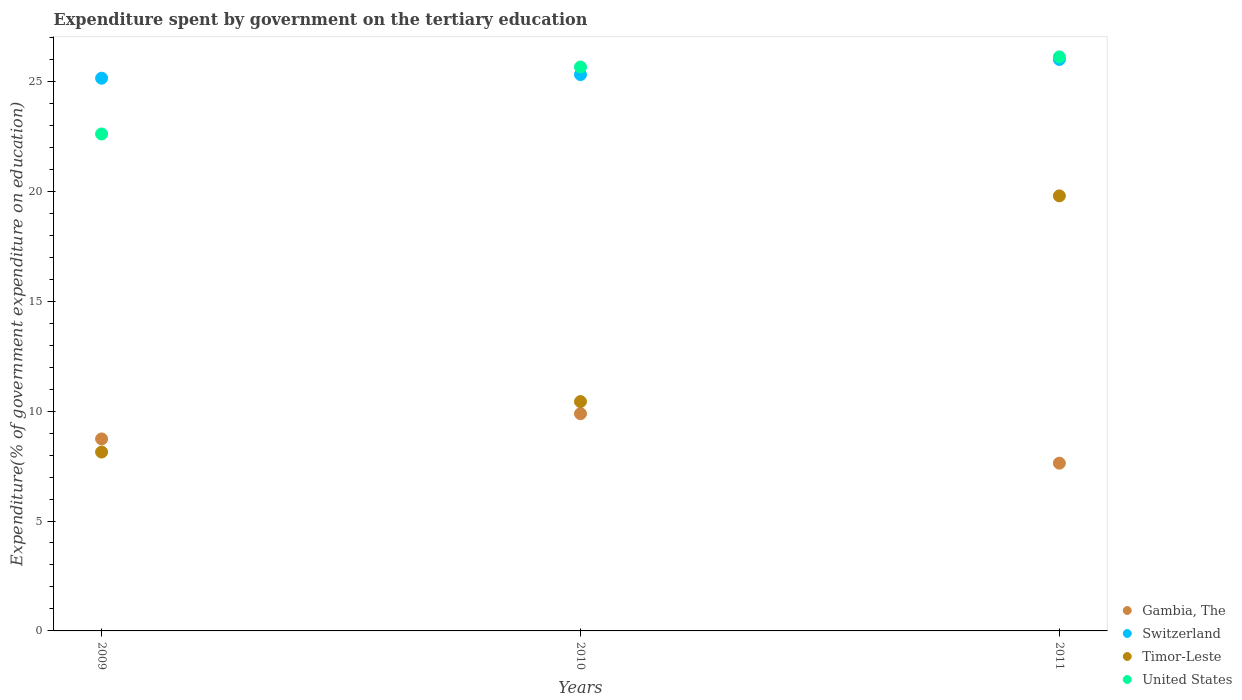What is the expenditure spent by government on the tertiary education in United States in 2011?
Your answer should be compact. 26.11. Across all years, what is the maximum expenditure spent by government on the tertiary education in Switzerland?
Provide a succinct answer. 26. Across all years, what is the minimum expenditure spent by government on the tertiary education in Gambia, The?
Keep it short and to the point. 7.63. In which year was the expenditure spent by government on the tertiary education in Switzerland maximum?
Keep it short and to the point. 2011. What is the total expenditure spent by government on the tertiary education in United States in the graph?
Your response must be concise. 74.37. What is the difference between the expenditure spent by government on the tertiary education in Switzerland in 2009 and that in 2010?
Offer a very short reply. -0.16. What is the difference between the expenditure spent by government on the tertiary education in Timor-Leste in 2010 and the expenditure spent by government on the tertiary education in Gambia, The in 2009?
Make the answer very short. 1.7. What is the average expenditure spent by government on the tertiary education in United States per year?
Your answer should be very brief. 24.79. In the year 2009, what is the difference between the expenditure spent by government on the tertiary education in United States and expenditure spent by government on the tertiary education in Timor-Leste?
Make the answer very short. 14.47. What is the ratio of the expenditure spent by government on the tertiary education in United States in 2009 to that in 2011?
Ensure brevity in your answer.  0.87. Is the expenditure spent by government on the tertiary education in United States in 2009 less than that in 2010?
Provide a short and direct response. Yes. What is the difference between the highest and the second highest expenditure spent by government on the tertiary education in Gambia, The?
Your answer should be very brief. 1.15. What is the difference between the highest and the lowest expenditure spent by government on the tertiary education in United States?
Your answer should be compact. 3.51. Is it the case that in every year, the sum of the expenditure spent by government on the tertiary education in Switzerland and expenditure spent by government on the tertiary education in Timor-Leste  is greater than the sum of expenditure spent by government on the tertiary education in Gambia, The and expenditure spent by government on the tertiary education in United States?
Ensure brevity in your answer.  Yes. Is it the case that in every year, the sum of the expenditure spent by government on the tertiary education in United States and expenditure spent by government on the tertiary education in Timor-Leste  is greater than the expenditure spent by government on the tertiary education in Gambia, The?
Offer a very short reply. Yes. Is the expenditure spent by government on the tertiary education in United States strictly greater than the expenditure spent by government on the tertiary education in Gambia, The over the years?
Offer a terse response. Yes. How many dotlines are there?
Keep it short and to the point. 4. How many years are there in the graph?
Your answer should be compact. 3. What is the difference between two consecutive major ticks on the Y-axis?
Offer a very short reply. 5. Are the values on the major ticks of Y-axis written in scientific E-notation?
Your answer should be very brief. No. Does the graph contain grids?
Your answer should be very brief. No. Where does the legend appear in the graph?
Your answer should be compact. Bottom right. What is the title of the graph?
Keep it short and to the point. Expenditure spent by government on the tertiary education. Does "Iraq" appear as one of the legend labels in the graph?
Keep it short and to the point. No. What is the label or title of the Y-axis?
Ensure brevity in your answer.  Expenditure(% of government expenditure on education). What is the Expenditure(% of government expenditure on education) of Gambia, The in 2009?
Your answer should be compact. 8.73. What is the Expenditure(% of government expenditure on education) of Switzerland in 2009?
Give a very brief answer. 25.14. What is the Expenditure(% of government expenditure on education) of Timor-Leste in 2009?
Your answer should be very brief. 8.14. What is the Expenditure(% of government expenditure on education) of United States in 2009?
Keep it short and to the point. 22.61. What is the Expenditure(% of government expenditure on education) of Gambia, The in 2010?
Make the answer very short. 9.88. What is the Expenditure(% of government expenditure on education) in Switzerland in 2010?
Your answer should be compact. 25.31. What is the Expenditure(% of government expenditure on education) in Timor-Leste in 2010?
Your answer should be very brief. 10.43. What is the Expenditure(% of government expenditure on education) of United States in 2010?
Your answer should be very brief. 25.65. What is the Expenditure(% of government expenditure on education) of Gambia, The in 2011?
Offer a terse response. 7.63. What is the Expenditure(% of government expenditure on education) in Switzerland in 2011?
Make the answer very short. 26. What is the Expenditure(% of government expenditure on education) in Timor-Leste in 2011?
Offer a terse response. 19.79. What is the Expenditure(% of government expenditure on education) in United States in 2011?
Provide a succinct answer. 26.11. Across all years, what is the maximum Expenditure(% of government expenditure on education) in Gambia, The?
Provide a succinct answer. 9.88. Across all years, what is the maximum Expenditure(% of government expenditure on education) in Switzerland?
Your answer should be very brief. 26. Across all years, what is the maximum Expenditure(% of government expenditure on education) in Timor-Leste?
Provide a succinct answer. 19.79. Across all years, what is the maximum Expenditure(% of government expenditure on education) of United States?
Offer a terse response. 26.11. Across all years, what is the minimum Expenditure(% of government expenditure on education) in Gambia, The?
Your answer should be very brief. 7.63. Across all years, what is the minimum Expenditure(% of government expenditure on education) of Switzerland?
Ensure brevity in your answer.  25.14. Across all years, what is the minimum Expenditure(% of government expenditure on education) in Timor-Leste?
Offer a terse response. 8.14. Across all years, what is the minimum Expenditure(% of government expenditure on education) of United States?
Offer a terse response. 22.61. What is the total Expenditure(% of government expenditure on education) in Gambia, The in the graph?
Make the answer very short. 26.25. What is the total Expenditure(% of government expenditure on education) of Switzerland in the graph?
Make the answer very short. 76.45. What is the total Expenditure(% of government expenditure on education) of Timor-Leste in the graph?
Your answer should be very brief. 38.36. What is the total Expenditure(% of government expenditure on education) of United States in the graph?
Ensure brevity in your answer.  74.37. What is the difference between the Expenditure(% of government expenditure on education) in Gambia, The in 2009 and that in 2010?
Provide a short and direct response. -1.15. What is the difference between the Expenditure(% of government expenditure on education) in Switzerland in 2009 and that in 2010?
Give a very brief answer. -0.16. What is the difference between the Expenditure(% of government expenditure on education) of Timor-Leste in 2009 and that in 2010?
Your answer should be compact. -2.3. What is the difference between the Expenditure(% of government expenditure on education) in United States in 2009 and that in 2010?
Give a very brief answer. -3.05. What is the difference between the Expenditure(% of government expenditure on education) in Gambia, The in 2009 and that in 2011?
Your answer should be compact. 1.1. What is the difference between the Expenditure(% of government expenditure on education) of Switzerland in 2009 and that in 2011?
Your answer should be very brief. -0.85. What is the difference between the Expenditure(% of government expenditure on education) of Timor-Leste in 2009 and that in 2011?
Provide a short and direct response. -11.65. What is the difference between the Expenditure(% of government expenditure on education) of United States in 2009 and that in 2011?
Offer a terse response. -3.51. What is the difference between the Expenditure(% of government expenditure on education) in Gambia, The in 2010 and that in 2011?
Offer a very short reply. 2.25. What is the difference between the Expenditure(% of government expenditure on education) in Switzerland in 2010 and that in 2011?
Offer a terse response. -0.69. What is the difference between the Expenditure(% of government expenditure on education) in Timor-Leste in 2010 and that in 2011?
Provide a succinct answer. -9.36. What is the difference between the Expenditure(% of government expenditure on education) of United States in 2010 and that in 2011?
Offer a very short reply. -0.46. What is the difference between the Expenditure(% of government expenditure on education) in Gambia, The in 2009 and the Expenditure(% of government expenditure on education) in Switzerland in 2010?
Give a very brief answer. -16.57. What is the difference between the Expenditure(% of government expenditure on education) of Gambia, The in 2009 and the Expenditure(% of government expenditure on education) of Timor-Leste in 2010?
Your response must be concise. -1.7. What is the difference between the Expenditure(% of government expenditure on education) in Gambia, The in 2009 and the Expenditure(% of government expenditure on education) in United States in 2010?
Make the answer very short. -16.92. What is the difference between the Expenditure(% of government expenditure on education) of Switzerland in 2009 and the Expenditure(% of government expenditure on education) of Timor-Leste in 2010?
Offer a terse response. 14.71. What is the difference between the Expenditure(% of government expenditure on education) in Switzerland in 2009 and the Expenditure(% of government expenditure on education) in United States in 2010?
Give a very brief answer. -0.51. What is the difference between the Expenditure(% of government expenditure on education) of Timor-Leste in 2009 and the Expenditure(% of government expenditure on education) of United States in 2010?
Offer a very short reply. -17.52. What is the difference between the Expenditure(% of government expenditure on education) in Gambia, The in 2009 and the Expenditure(% of government expenditure on education) in Switzerland in 2011?
Provide a succinct answer. -17.26. What is the difference between the Expenditure(% of government expenditure on education) in Gambia, The in 2009 and the Expenditure(% of government expenditure on education) in Timor-Leste in 2011?
Your answer should be very brief. -11.06. What is the difference between the Expenditure(% of government expenditure on education) of Gambia, The in 2009 and the Expenditure(% of government expenditure on education) of United States in 2011?
Your answer should be compact. -17.38. What is the difference between the Expenditure(% of government expenditure on education) in Switzerland in 2009 and the Expenditure(% of government expenditure on education) in Timor-Leste in 2011?
Provide a succinct answer. 5.35. What is the difference between the Expenditure(% of government expenditure on education) of Switzerland in 2009 and the Expenditure(% of government expenditure on education) of United States in 2011?
Your response must be concise. -0.97. What is the difference between the Expenditure(% of government expenditure on education) in Timor-Leste in 2009 and the Expenditure(% of government expenditure on education) in United States in 2011?
Provide a short and direct response. -17.98. What is the difference between the Expenditure(% of government expenditure on education) of Gambia, The in 2010 and the Expenditure(% of government expenditure on education) of Switzerland in 2011?
Offer a very short reply. -16.11. What is the difference between the Expenditure(% of government expenditure on education) of Gambia, The in 2010 and the Expenditure(% of government expenditure on education) of Timor-Leste in 2011?
Provide a succinct answer. -9.91. What is the difference between the Expenditure(% of government expenditure on education) of Gambia, The in 2010 and the Expenditure(% of government expenditure on education) of United States in 2011?
Provide a succinct answer. -16.23. What is the difference between the Expenditure(% of government expenditure on education) in Switzerland in 2010 and the Expenditure(% of government expenditure on education) in Timor-Leste in 2011?
Offer a terse response. 5.52. What is the difference between the Expenditure(% of government expenditure on education) in Switzerland in 2010 and the Expenditure(% of government expenditure on education) in United States in 2011?
Ensure brevity in your answer.  -0.81. What is the difference between the Expenditure(% of government expenditure on education) of Timor-Leste in 2010 and the Expenditure(% of government expenditure on education) of United States in 2011?
Your answer should be compact. -15.68. What is the average Expenditure(% of government expenditure on education) of Gambia, The per year?
Your response must be concise. 8.75. What is the average Expenditure(% of government expenditure on education) in Switzerland per year?
Provide a succinct answer. 25.48. What is the average Expenditure(% of government expenditure on education) in Timor-Leste per year?
Provide a short and direct response. 12.79. What is the average Expenditure(% of government expenditure on education) in United States per year?
Provide a short and direct response. 24.79. In the year 2009, what is the difference between the Expenditure(% of government expenditure on education) of Gambia, The and Expenditure(% of government expenditure on education) of Switzerland?
Make the answer very short. -16.41. In the year 2009, what is the difference between the Expenditure(% of government expenditure on education) in Gambia, The and Expenditure(% of government expenditure on education) in Timor-Leste?
Make the answer very short. 0.6. In the year 2009, what is the difference between the Expenditure(% of government expenditure on education) in Gambia, The and Expenditure(% of government expenditure on education) in United States?
Your answer should be very brief. -13.87. In the year 2009, what is the difference between the Expenditure(% of government expenditure on education) of Switzerland and Expenditure(% of government expenditure on education) of Timor-Leste?
Your response must be concise. 17.01. In the year 2009, what is the difference between the Expenditure(% of government expenditure on education) of Switzerland and Expenditure(% of government expenditure on education) of United States?
Offer a very short reply. 2.54. In the year 2009, what is the difference between the Expenditure(% of government expenditure on education) of Timor-Leste and Expenditure(% of government expenditure on education) of United States?
Provide a succinct answer. -14.47. In the year 2010, what is the difference between the Expenditure(% of government expenditure on education) of Gambia, The and Expenditure(% of government expenditure on education) of Switzerland?
Provide a short and direct response. -15.43. In the year 2010, what is the difference between the Expenditure(% of government expenditure on education) in Gambia, The and Expenditure(% of government expenditure on education) in Timor-Leste?
Make the answer very short. -0.55. In the year 2010, what is the difference between the Expenditure(% of government expenditure on education) in Gambia, The and Expenditure(% of government expenditure on education) in United States?
Offer a terse response. -15.77. In the year 2010, what is the difference between the Expenditure(% of government expenditure on education) of Switzerland and Expenditure(% of government expenditure on education) of Timor-Leste?
Your response must be concise. 14.87. In the year 2010, what is the difference between the Expenditure(% of government expenditure on education) of Switzerland and Expenditure(% of government expenditure on education) of United States?
Ensure brevity in your answer.  -0.35. In the year 2010, what is the difference between the Expenditure(% of government expenditure on education) of Timor-Leste and Expenditure(% of government expenditure on education) of United States?
Your answer should be compact. -15.22. In the year 2011, what is the difference between the Expenditure(% of government expenditure on education) in Gambia, The and Expenditure(% of government expenditure on education) in Switzerland?
Ensure brevity in your answer.  -18.37. In the year 2011, what is the difference between the Expenditure(% of government expenditure on education) of Gambia, The and Expenditure(% of government expenditure on education) of Timor-Leste?
Give a very brief answer. -12.16. In the year 2011, what is the difference between the Expenditure(% of government expenditure on education) in Gambia, The and Expenditure(% of government expenditure on education) in United States?
Ensure brevity in your answer.  -18.48. In the year 2011, what is the difference between the Expenditure(% of government expenditure on education) of Switzerland and Expenditure(% of government expenditure on education) of Timor-Leste?
Ensure brevity in your answer.  6.21. In the year 2011, what is the difference between the Expenditure(% of government expenditure on education) of Switzerland and Expenditure(% of government expenditure on education) of United States?
Your answer should be very brief. -0.12. In the year 2011, what is the difference between the Expenditure(% of government expenditure on education) of Timor-Leste and Expenditure(% of government expenditure on education) of United States?
Give a very brief answer. -6.32. What is the ratio of the Expenditure(% of government expenditure on education) in Gambia, The in 2009 to that in 2010?
Give a very brief answer. 0.88. What is the ratio of the Expenditure(% of government expenditure on education) in Timor-Leste in 2009 to that in 2010?
Offer a very short reply. 0.78. What is the ratio of the Expenditure(% of government expenditure on education) of United States in 2009 to that in 2010?
Provide a short and direct response. 0.88. What is the ratio of the Expenditure(% of government expenditure on education) in Gambia, The in 2009 to that in 2011?
Make the answer very short. 1.14. What is the ratio of the Expenditure(% of government expenditure on education) in Switzerland in 2009 to that in 2011?
Your answer should be very brief. 0.97. What is the ratio of the Expenditure(% of government expenditure on education) of Timor-Leste in 2009 to that in 2011?
Keep it short and to the point. 0.41. What is the ratio of the Expenditure(% of government expenditure on education) in United States in 2009 to that in 2011?
Your answer should be compact. 0.87. What is the ratio of the Expenditure(% of government expenditure on education) in Gambia, The in 2010 to that in 2011?
Provide a short and direct response. 1.29. What is the ratio of the Expenditure(% of government expenditure on education) of Switzerland in 2010 to that in 2011?
Offer a very short reply. 0.97. What is the ratio of the Expenditure(% of government expenditure on education) of Timor-Leste in 2010 to that in 2011?
Keep it short and to the point. 0.53. What is the ratio of the Expenditure(% of government expenditure on education) in United States in 2010 to that in 2011?
Provide a short and direct response. 0.98. What is the difference between the highest and the second highest Expenditure(% of government expenditure on education) of Gambia, The?
Give a very brief answer. 1.15. What is the difference between the highest and the second highest Expenditure(% of government expenditure on education) of Switzerland?
Your answer should be very brief. 0.69. What is the difference between the highest and the second highest Expenditure(% of government expenditure on education) in Timor-Leste?
Your response must be concise. 9.36. What is the difference between the highest and the second highest Expenditure(% of government expenditure on education) of United States?
Ensure brevity in your answer.  0.46. What is the difference between the highest and the lowest Expenditure(% of government expenditure on education) of Gambia, The?
Your answer should be very brief. 2.25. What is the difference between the highest and the lowest Expenditure(% of government expenditure on education) of Switzerland?
Your answer should be compact. 0.85. What is the difference between the highest and the lowest Expenditure(% of government expenditure on education) of Timor-Leste?
Give a very brief answer. 11.65. What is the difference between the highest and the lowest Expenditure(% of government expenditure on education) in United States?
Your response must be concise. 3.51. 